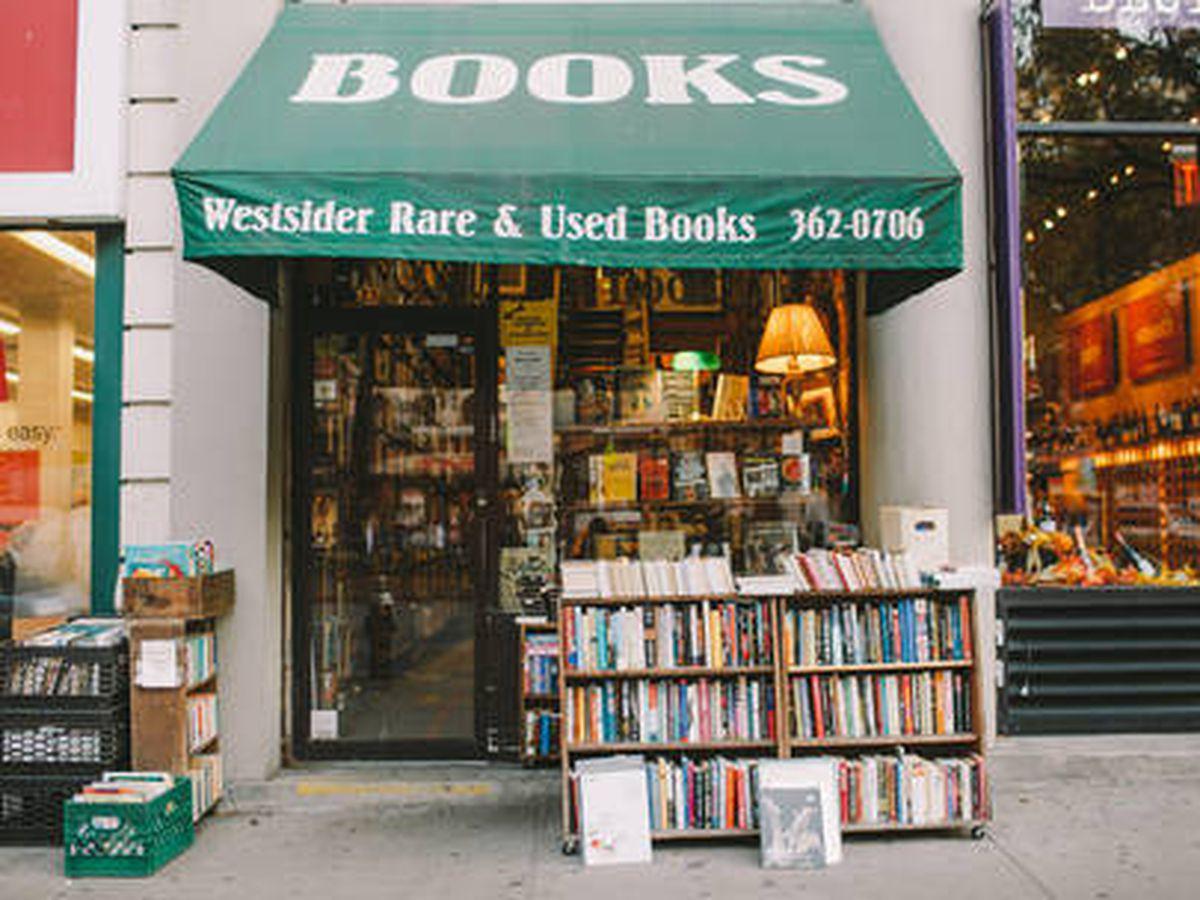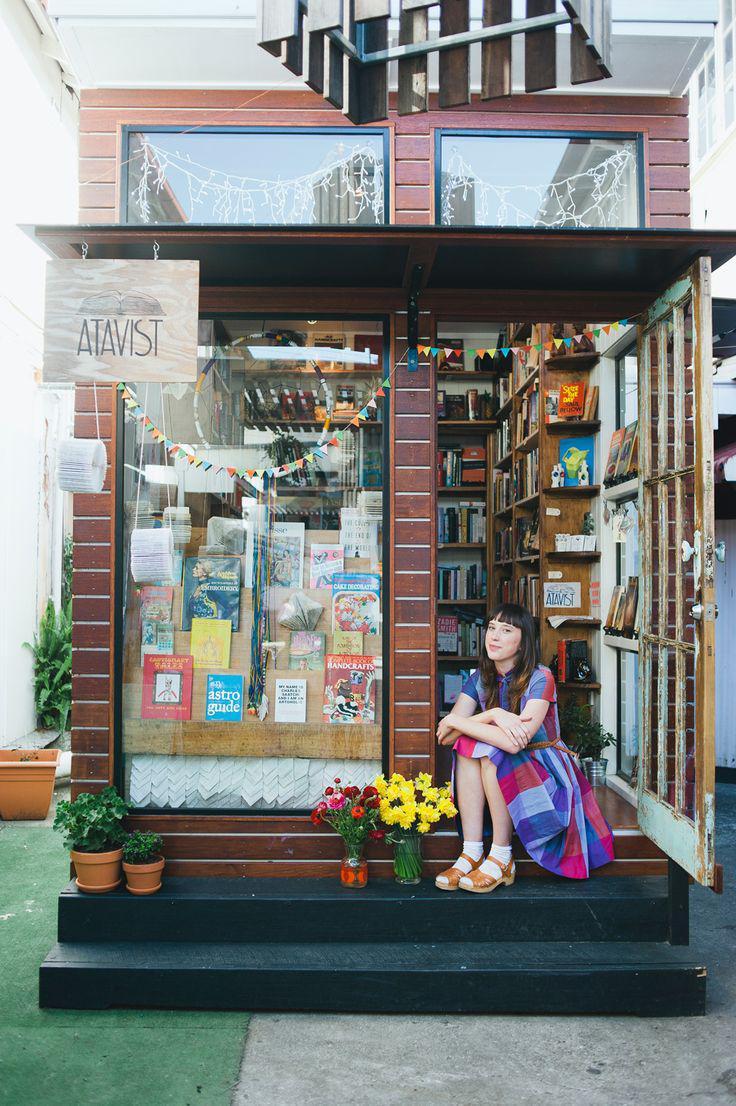The first image is the image on the left, the second image is the image on the right. For the images shown, is this caption "An image shows multiple non-hanging containers of flowering plants in front of a shop's exterior." true? Answer yes or no. Yes. The first image is the image on the left, the second image is the image on the right. For the images shown, is this caption "Both images shown the exterior of a bookstore." true? Answer yes or no. Yes. 